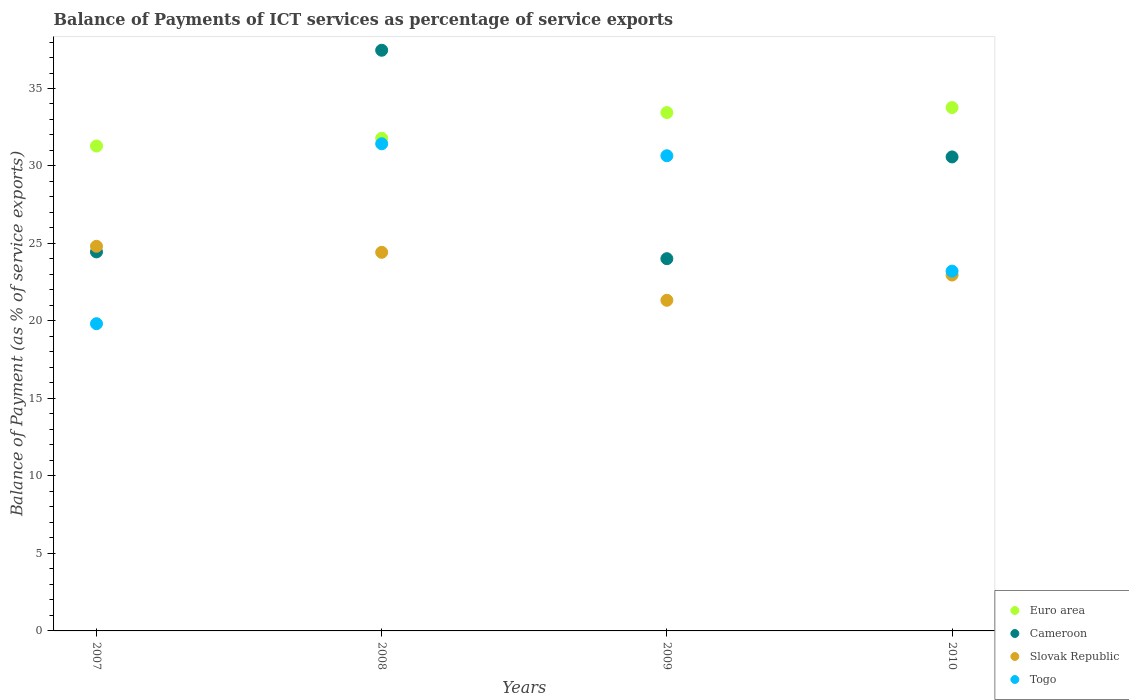What is the balance of payments of ICT services in Cameroon in 2008?
Give a very brief answer. 37.47. Across all years, what is the maximum balance of payments of ICT services in Togo?
Offer a very short reply. 31.43. Across all years, what is the minimum balance of payments of ICT services in Slovak Republic?
Keep it short and to the point. 21.33. In which year was the balance of payments of ICT services in Euro area maximum?
Provide a succinct answer. 2010. What is the total balance of payments of ICT services in Slovak Republic in the graph?
Offer a terse response. 93.55. What is the difference between the balance of payments of ICT services in Cameroon in 2008 and that in 2009?
Keep it short and to the point. 13.45. What is the difference between the balance of payments of ICT services in Slovak Republic in 2007 and the balance of payments of ICT services in Cameroon in 2008?
Your answer should be compact. -12.65. What is the average balance of payments of ICT services in Togo per year?
Offer a terse response. 26.28. In the year 2007, what is the difference between the balance of payments of ICT services in Togo and balance of payments of ICT services in Euro area?
Your answer should be very brief. -11.47. What is the ratio of the balance of payments of ICT services in Cameroon in 2008 to that in 2010?
Your answer should be compact. 1.23. What is the difference between the highest and the second highest balance of payments of ICT services in Euro area?
Offer a very short reply. 0.32. What is the difference between the highest and the lowest balance of payments of ICT services in Cameroon?
Make the answer very short. 13.45. In how many years, is the balance of payments of ICT services in Togo greater than the average balance of payments of ICT services in Togo taken over all years?
Give a very brief answer. 2. Is it the case that in every year, the sum of the balance of payments of ICT services in Slovak Republic and balance of payments of ICT services in Euro area  is greater than the sum of balance of payments of ICT services in Cameroon and balance of payments of ICT services in Togo?
Ensure brevity in your answer.  No. Is the balance of payments of ICT services in Cameroon strictly greater than the balance of payments of ICT services in Slovak Republic over the years?
Provide a short and direct response. No. Is the balance of payments of ICT services in Cameroon strictly less than the balance of payments of ICT services in Slovak Republic over the years?
Provide a succinct answer. No. How many years are there in the graph?
Keep it short and to the point. 4. Does the graph contain any zero values?
Offer a terse response. No. What is the title of the graph?
Ensure brevity in your answer.  Balance of Payments of ICT services as percentage of service exports. What is the label or title of the Y-axis?
Make the answer very short. Balance of Payment (as % of service exports). What is the Balance of Payment (as % of service exports) of Euro area in 2007?
Keep it short and to the point. 31.29. What is the Balance of Payment (as % of service exports) in Cameroon in 2007?
Provide a succinct answer. 24.46. What is the Balance of Payment (as % of service exports) in Slovak Republic in 2007?
Offer a very short reply. 24.82. What is the Balance of Payment (as % of service exports) of Togo in 2007?
Offer a terse response. 19.82. What is the Balance of Payment (as % of service exports) in Euro area in 2008?
Your answer should be compact. 31.79. What is the Balance of Payment (as % of service exports) of Cameroon in 2008?
Your response must be concise. 37.47. What is the Balance of Payment (as % of service exports) in Slovak Republic in 2008?
Ensure brevity in your answer.  24.43. What is the Balance of Payment (as % of service exports) of Togo in 2008?
Offer a terse response. 31.43. What is the Balance of Payment (as % of service exports) in Euro area in 2009?
Ensure brevity in your answer.  33.45. What is the Balance of Payment (as % of service exports) in Cameroon in 2009?
Your answer should be compact. 24.02. What is the Balance of Payment (as % of service exports) of Slovak Republic in 2009?
Your answer should be very brief. 21.33. What is the Balance of Payment (as % of service exports) of Togo in 2009?
Give a very brief answer. 30.66. What is the Balance of Payment (as % of service exports) of Euro area in 2010?
Ensure brevity in your answer.  33.77. What is the Balance of Payment (as % of service exports) of Cameroon in 2010?
Keep it short and to the point. 30.58. What is the Balance of Payment (as % of service exports) of Slovak Republic in 2010?
Keep it short and to the point. 22.96. What is the Balance of Payment (as % of service exports) in Togo in 2010?
Your answer should be very brief. 23.22. Across all years, what is the maximum Balance of Payment (as % of service exports) in Euro area?
Your answer should be very brief. 33.77. Across all years, what is the maximum Balance of Payment (as % of service exports) in Cameroon?
Your answer should be very brief. 37.47. Across all years, what is the maximum Balance of Payment (as % of service exports) in Slovak Republic?
Your answer should be very brief. 24.82. Across all years, what is the maximum Balance of Payment (as % of service exports) in Togo?
Your answer should be very brief. 31.43. Across all years, what is the minimum Balance of Payment (as % of service exports) of Euro area?
Provide a succinct answer. 31.29. Across all years, what is the minimum Balance of Payment (as % of service exports) in Cameroon?
Offer a terse response. 24.02. Across all years, what is the minimum Balance of Payment (as % of service exports) in Slovak Republic?
Your answer should be very brief. 21.33. Across all years, what is the minimum Balance of Payment (as % of service exports) of Togo?
Offer a terse response. 19.82. What is the total Balance of Payment (as % of service exports) of Euro area in the graph?
Ensure brevity in your answer.  130.3. What is the total Balance of Payment (as % of service exports) of Cameroon in the graph?
Offer a very short reply. 116.53. What is the total Balance of Payment (as % of service exports) in Slovak Republic in the graph?
Provide a short and direct response. 93.55. What is the total Balance of Payment (as % of service exports) in Togo in the graph?
Offer a terse response. 105.13. What is the difference between the Balance of Payment (as % of service exports) of Euro area in 2007 and that in 2008?
Offer a terse response. -0.5. What is the difference between the Balance of Payment (as % of service exports) of Cameroon in 2007 and that in 2008?
Keep it short and to the point. -13.01. What is the difference between the Balance of Payment (as % of service exports) of Slovak Republic in 2007 and that in 2008?
Provide a short and direct response. 0.39. What is the difference between the Balance of Payment (as % of service exports) in Togo in 2007 and that in 2008?
Give a very brief answer. -11.61. What is the difference between the Balance of Payment (as % of service exports) in Euro area in 2007 and that in 2009?
Ensure brevity in your answer.  -2.16. What is the difference between the Balance of Payment (as % of service exports) in Cameroon in 2007 and that in 2009?
Your answer should be compact. 0.44. What is the difference between the Balance of Payment (as % of service exports) in Slovak Republic in 2007 and that in 2009?
Provide a short and direct response. 3.48. What is the difference between the Balance of Payment (as % of service exports) in Togo in 2007 and that in 2009?
Offer a very short reply. -10.84. What is the difference between the Balance of Payment (as % of service exports) of Euro area in 2007 and that in 2010?
Ensure brevity in your answer.  -2.48. What is the difference between the Balance of Payment (as % of service exports) of Cameroon in 2007 and that in 2010?
Provide a succinct answer. -6.13. What is the difference between the Balance of Payment (as % of service exports) of Slovak Republic in 2007 and that in 2010?
Give a very brief answer. 1.85. What is the difference between the Balance of Payment (as % of service exports) in Togo in 2007 and that in 2010?
Offer a very short reply. -3.39. What is the difference between the Balance of Payment (as % of service exports) of Euro area in 2008 and that in 2009?
Provide a succinct answer. -1.66. What is the difference between the Balance of Payment (as % of service exports) of Cameroon in 2008 and that in 2009?
Give a very brief answer. 13.45. What is the difference between the Balance of Payment (as % of service exports) in Slovak Republic in 2008 and that in 2009?
Provide a short and direct response. 3.09. What is the difference between the Balance of Payment (as % of service exports) of Togo in 2008 and that in 2009?
Make the answer very short. 0.77. What is the difference between the Balance of Payment (as % of service exports) of Euro area in 2008 and that in 2010?
Your answer should be very brief. -1.98. What is the difference between the Balance of Payment (as % of service exports) of Cameroon in 2008 and that in 2010?
Provide a succinct answer. 6.88. What is the difference between the Balance of Payment (as % of service exports) of Slovak Republic in 2008 and that in 2010?
Your answer should be compact. 1.47. What is the difference between the Balance of Payment (as % of service exports) of Togo in 2008 and that in 2010?
Offer a very short reply. 8.22. What is the difference between the Balance of Payment (as % of service exports) in Euro area in 2009 and that in 2010?
Your response must be concise. -0.32. What is the difference between the Balance of Payment (as % of service exports) in Cameroon in 2009 and that in 2010?
Keep it short and to the point. -6.57. What is the difference between the Balance of Payment (as % of service exports) of Slovak Republic in 2009 and that in 2010?
Your answer should be very brief. -1.63. What is the difference between the Balance of Payment (as % of service exports) of Togo in 2009 and that in 2010?
Ensure brevity in your answer.  7.44. What is the difference between the Balance of Payment (as % of service exports) of Euro area in 2007 and the Balance of Payment (as % of service exports) of Cameroon in 2008?
Your answer should be very brief. -6.18. What is the difference between the Balance of Payment (as % of service exports) in Euro area in 2007 and the Balance of Payment (as % of service exports) in Slovak Republic in 2008?
Provide a succinct answer. 6.86. What is the difference between the Balance of Payment (as % of service exports) in Euro area in 2007 and the Balance of Payment (as % of service exports) in Togo in 2008?
Your answer should be very brief. -0.14. What is the difference between the Balance of Payment (as % of service exports) of Cameroon in 2007 and the Balance of Payment (as % of service exports) of Slovak Republic in 2008?
Make the answer very short. 0.03. What is the difference between the Balance of Payment (as % of service exports) in Cameroon in 2007 and the Balance of Payment (as % of service exports) in Togo in 2008?
Provide a short and direct response. -6.98. What is the difference between the Balance of Payment (as % of service exports) in Slovak Republic in 2007 and the Balance of Payment (as % of service exports) in Togo in 2008?
Your answer should be compact. -6.62. What is the difference between the Balance of Payment (as % of service exports) of Euro area in 2007 and the Balance of Payment (as % of service exports) of Cameroon in 2009?
Keep it short and to the point. 7.27. What is the difference between the Balance of Payment (as % of service exports) of Euro area in 2007 and the Balance of Payment (as % of service exports) of Slovak Republic in 2009?
Give a very brief answer. 9.95. What is the difference between the Balance of Payment (as % of service exports) in Euro area in 2007 and the Balance of Payment (as % of service exports) in Togo in 2009?
Ensure brevity in your answer.  0.63. What is the difference between the Balance of Payment (as % of service exports) in Cameroon in 2007 and the Balance of Payment (as % of service exports) in Slovak Republic in 2009?
Your answer should be very brief. 3.12. What is the difference between the Balance of Payment (as % of service exports) of Cameroon in 2007 and the Balance of Payment (as % of service exports) of Togo in 2009?
Give a very brief answer. -6.2. What is the difference between the Balance of Payment (as % of service exports) in Slovak Republic in 2007 and the Balance of Payment (as % of service exports) in Togo in 2009?
Keep it short and to the point. -5.84. What is the difference between the Balance of Payment (as % of service exports) of Euro area in 2007 and the Balance of Payment (as % of service exports) of Cameroon in 2010?
Keep it short and to the point. 0.7. What is the difference between the Balance of Payment (as % of service exports) of Euro area in 2007 and the Balance of Payment (as % of service exports) of Slovak Republic in 2010?
Offer a very short reply. 8.33. What is the difference between the Balance of Payment (as % of service exports) of Euro area in 2007 and the Balance of Payment (as % of service exports) of Togo in 2010?
Offer a terse response. 8.07. What is the difference between the Balance of Payment (as % of service exports) in Cameroon in 2007 and the Balance of Payment (as % of service exports) in Slovak Republic in 2010?
Provide a short and direct response. 1.49. What is the difference between the Balance of Payment (as % of service exports) of Cameroon in 2007 and the Balance of Payment (as % of service exports) of Togo in 2010?
Your answer should be compact. 1.24. What is the difference between the Balance of Payment (as % of service exports) in Slovak Republic in 2007 and the Balance of Payment (as % of service exports) in Togo in 2010?
Keep it short and to the point. 1.6. What is the difference between the Balance of Payment (as % of service exports) of Euro area in 2008 and the Balance of Payment (as % of service exports) of Cameroon in 2009?
Ensure brevity in your answer.  7.77. What is the difference between the Balance of Payment (as % of service exports) of Euro area in 2008 and the Balance of Payment (as % of service exports) of Slovak Republic in 2009?
Offer a very short reply. 10.45. What is the difference between the Balance of Payment (as % of service exports) in Euro area in 2008 and the Balance of Payment (as % of service exports) in Togo in 2009?
Ensure brevity in your answer.  1.13. What is the difference between the Balance of Payment (as % of service exports) in Cameroon in 2008 and the Balance of Payment (as % of service exports) in Slovak Republic in 2009?
Offer a very short reply. 16.13. What is the difference between the Balance of Payment (as % of service exports) of Cameroon in 2008 and the Balance of Payment (as % of service exports) of Togo in 2009?
Provide a short and direct response. 6.81. What is the difference between the Balance of Payment (as % of service exports) of Slovak Republic in 2008 and the Balance of Payment (as % of service exports) of Togo in 2009?
Ensure brevity in your answer.  -6.23. What is the difference between the Balance of Payment (as % of service exports) in Euro area in 2008 and the Balance of Payment (as % of service exports) in Cameroon in 2010?
Offer a terse response. 1.2. What is the difference between the Balance of Payment (as % of service exports) of Euro area in 2008 and the Balance of Payment (as % of service exports) of Slovak Republic in 2010?
Make the answer very short. 8.82. What is the difference between the Balance of Payment (as % of service exports) in Euro area in 2008 and the Balance of Payment (as % of service exports) in Togo in 2010?
Your answer should be very brief. 8.57. What is the difference between the Balance of Payment (as % of service exports) of Cameroon in 2008 and the Balance of Payment (as % of service exports) of Slovak Republic in 2010?
Your answer should be compact. 14.5. What is the difference between the Balance of Payment (as % of service exports) of Cameroon in 2008 and the Balance of Payment (as % of service exports) of Togo in 2010?
Your answer should be compact. 14.25. What is the difference between the Balance of Payment (as % of service exports) of Slovak Republic in 2008 and the Balance of Payment (as % of service exports) of Togo in 2010?
Provide a succinct answer. 1.21. What is the difference between the Balance of Payment (as % of service exports) of Euro area in 2009 and the Balance of Payment (as % of service exports) of Cameroon in 2010?
Your answer should be compact. 2.86. What is the difference between the Balance of Payment (as % of service exports) of Euro area in 2009 and the Balance of Payment (as % of service exports) of Slovak Republic in 2010?
Offer a very short reply. 10.48. What is the difference between the Balance of Payment (as % of service exports) in Euro area in 2009 and the Balance of Payment (as % of service exports) in Togo in 2010?
Offer a very short reply. 10.23. What is the difference between the Balance of Payment (as % of service exports) of Cameroon in 2009 and the Balance of Payment (as % of service exports) of Slovak Republic in 2010?
Your answer should be very brief. 1.05. What is the difference between the Balance of Payment (as % of service exports) in Cameroon in 2009 and the Balance of Payment (as % of service exports) in Togo in 2010?
Provide a short and direct response. 0.8. What is the difference between the Balance of Payment (as % of service exports) of Slovak Republic in 2009 and the Balance of Payment (as % of service exports) of Togo in 2010?
Provide a succinct answer. -1.88. What is the average Balance of Payment (as % of service exports) of Euro area per year?
Offer a terse response. 32.57. What is the average Balance of Payment (as % of service exports) in Cameroon per year?
Give a very brief answer. 29.13. What is the average Balance of Payment (as % of service exports) in Slovak Republic per year?
Give a very brief answer. 23.39. What is the average Balance of Payment (as % of service exports) of Togo per year?
Offer a very short reply. 26.28. In the year 2007, what is the difference between the Balance of Payment (as % of service exports) of Euro area and Balance of Payment (as % of service exports) of Cameroon?
Offer a very short reply. 6.83. In the year 2007, what is the difference between the Balance of Payment (as % of service exports) of Euro area and Balance of Payment (as % of service exports) of Slovak Republic?
Keep it short and to the point. 6.47. In the year 2007, what is the difference between the Balance of Payment (as % of service exports) in Euro area and Balance of Payment (as % of service exports) in Togo?
Keep it short and to the point. 11.47. In the year 2007, what is the difference between the Balance of Payment (as % of service exports) in Cameroon and Balance of Payment (as % of service exports) in Slovak Republic?
Offer a very short reply. -0.36. In the year 2007, what is the difference between the Balance of Payment (as % of service exports) of Cameroon and Balance of Payment (as % of service exports) of Togo?
Your response must be concise. 4.63. In the year 2007, what is the difference between the Balance of Payment (as % of service exports) in Slovak Republic and Balance of Payment (as % of service exports) in Togo?
Offer a terse response. 5. In the year 2008, what is the difference between the Balance of Payment (as % of service exports) of Euro area and Balance of Payment (as % of service exports) of Cameroon?
Keep it short and to the point. -5.68. In the year 2008, what is the difference between the Balance of Payment (as % of service exports) of Euro area and Balance of Payment (as % of service exports) of Slovak Republic?
Ensure brevity in your answer.  7.36. In the year 2008, what is the difference between the Balance of Payment (as % of service exports) in Euro area and Balance of Payment (as % of service exports) in Togo?
Offer a very short reply. 0.35. In the year 2008, what is the difference between the Balance of Payment (as % of service exports) of Cameroon and Balance of Payment (as % of service exports) of Slovak Republic?
Provide a succinct answer. 13.04. In the year 2008, what is the difference between the Balance of Payment (as % of service exports) of Cameroon and Balance of Payment (as % of service exports) of Togo?
Your response must be concise. 6.03. In the year 2008, what is the difference between the Balance of Payment (as % of service exports) in Slovak Republic and Balance of Payment (as % of service exports) in Togo?
Keep it short and to the point. -7. In the year 2009, what is the difference between the Balance of Payment (as % of service exports) of Euro area and Balance of Payment (as % of service exports) of Cameroon?
Keep it short and to the point. 9.43. In the year 2009, what is the difference between the Balance of Payment (as % of service exports) in Euro area and Balance of Payment (as % of service exports) in Slovak Republic?
Make the answer very short. 12.11. In the year 2009, what is the difference between the Balance of Payment (as % of service exports) in Euro area and Balance of Payment (as % of service exports) in Togo?
Keep it short and to the point. 2.79. In the year 2009, what is the difference between the Balance of Payment (as % of service exports) in Cameroon and Balance of Payment (as % of service exports) in Slovak Republic?
Keep it short and to the point. 2.68. In the year 2009, what is the difference between the Balance of Payment (as % of service exports) in Cameroon and Balance of Payment (as % of service exports) in Togo?
Keep it short and to the point. -6.64. In the year 2009, what is the difference between the Balance of Payment (as % of service exports) in Slovak Republic and Balance of Payment (as % of service exports) in Togo?
Make the answer very short. -9.33. In the year 2010, what is the difference between the Balance of Payment (as % of service exports) of Euro area and Balance of Payment (as % of service exports) of Cameroon?
Ensure brevity in your answer.  3.19. In the year 2010, what is the difference between the Balance of Payment (as % of service exports) of Euro area and Balance of Payment (as % of service exports) of Slovak Republic?
Offer a very short reply. 10.81. In the year 2010, what is the difference between the Balance of Payment (as % of service exports) of Euro area and Balance of Payment (as % of service exports) of Togo?
Offer a very short reply. 10.56. In the year 2010, what is the difference between the Balance of Payment (as % of service exports) of Cameroon and Balance of Payment (as % of service exports) of Slovak Republic?
Offer a very short reply. 7.62. In the year 2010, what is the difference between the Balance of Payment (as % of service exports) in Cameroon and Balance of Payment (as % of service exports) in Togo?
Offer a very short reply. 7.37. In the year 2010, what is the difference between the Balance of Payment (as % of service exports) of Slovak Republic and Balance of Payment (as % of service exports) of Togo?
Your answer should be compact. -0.25. What is the ratio of the Balance of Payment (as % of service exports) in Euro area in 2007 to that in 2008?
Your answer should be compact. 0.98. What is the ratio of the Balance of Payment (as % of service exports) of Cameroon in 2007 to that in 2008?
Offer a very short reply. 0.65. What is the ratio of the Balance of Payment (as % of service exports) in Slovak Republic in 2007 to that in 2008?
Keep it short and to the point. 1.02. What is the ratio of the Balance of Payment (as % of service exports) of Togo in 2007 to that in 2008?
Offer a very short reply. 0.63. What is the ratio of the Balance of Payment (as % of service exports) of Euro area in 2007 to that in 2009?
Ensure brevity in your answer.  0.94. What is the ratio of the Balance of Payment (as % of service exports) of Cameroon in 2007 to that in 2009?
Provide a short and direct response. 1.02. What is the ratio of the Balance of Payment (as % of service exports) of Slovak Republic in 2007 to that in 2009?
Offer a very short reply. 1.16. What is the ratio of the Balance of Payment (as % of service exports) in Togo in 2007 to that in 2009?
Your answer should be compact. 0.65. What is the ratio of the Balance of Payment (as % of service exports) in Euro area in 2007 to that in 2010?
Provide a short and direct response. 0.93. What is the ratio of the Balance of Payment (as % of service exports) of Cameroon in 2007 to that in 2010?
Provide a succinct answer. 0.8. What is the ratio of the Balance of Payment (as % of service exports) of Slovak Republic in 2007 to that in 2010?
Offer a very short reply. 1.08. What is the ratio of the Balance of Payment (as % of service exports) of Togo in 2007 to that in 2010?
Ensure brevity in your answer.  0.85. What is the ratio of the Balance of Payment (as % of service exports) in Euro area in 2008 to that in 2009?
Your response must be concise. 0.95. What is the ratio of the Balance of Payment (as % of service exports) of Cameroon in 2008 to that in 2009?
Offer a very short reply. 1.56. What is the ratio of the Balance of Payment (as % of service exports) of Slovak Republic in 2008 to that in 2009?
Your answer should be very brief. 1.15. What is the ratio of the Balance of Payment (as % of service exports) in Togo in 2008 to that in 2009?
Give a very brief answer. 1.03. What is the ratio of the Balance of Payment (as % of service exports) in Cameroon in 2008 to that in 2010?
Make the answer very short. 1.23. What is the ratio of the Balance of Payment (as % of service exports) in Slovak Republic in 2008 to that in 2010?
Your answer should be compact. 1.06. What is the ratio of the Balance of Payment (as % of service exports) of Togo in 2008 to that in 2010?
Your answer should be compact. 1.35. What is the ratio of the Balance of Payment (as % of service exports) of Cameroon in 2009 to that in 2010?
Provide a short and direct response. 0.79. What is the ratio of the Balance of Payment (as % of service exports) in Slovak Republic in 2009 to that in 2010?
Keep it short and to the point. 0.93. What is the ratio of the Balance of Payment (as % of service exports) of Togo in 2009 to that in 2010?
Your response must be concise. 1.32. What is the difference between the highest and the second highest Balance of Payment (as % of service exports) in Euro area?
Make the answer very short. 0.32. What is the difference between the highest and the second highest Balance of Payment (as % of service exports) of Cameroon?
Offer a very short reply. 6.88. What is the difference between the highest and the second highest Balance of Payment (as % of service exports) in Slovak Republic?
Your response must be concise. 0.39. What is the difference between the highest and the second highest Balance of Payment (as % of service exports) of Togo?
Your response must be concise. 0.77. What is the difference between the highest and the lowest Balance of Payment (as % of service exports) of Euro area?
Make the answer very short. 2.48. What is the difference between the highest and the lowest Balance of Payment (as % of service exports) of Cameroon?
Your answer should be compact. 13.45. What is the difference between the highest and the lowest Balance of Payment (as % of service exports) of Slovak Republic?
Ensure brevity in your answer.  3.48. What is the difference between the highest and the lowest Balance of Payment (as % of service exports) in Togo?
Your answer should be very brief. 11.61. 